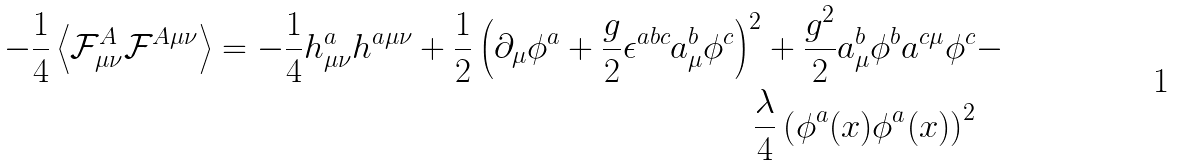Convert formula to latex. <formula><loc_0><loc_0><loc_500><loc_500>- \frac { 1 } { 4 } \left \langle \mathcal { F } ^ { A } _ { \mu \nu } \mathcal { F } ^ { A \mu \nu } \right \rangle = - \frac { 1 } { 4 } h ^ { a } _ { \mu \nu } h ^ { a \mu \nu } + \frac { 1 } { 2 } \left ( \partial _ { \mu } \phi ^ { a } + \frac { g } { 2 } \epsilon ^ { a b c } a ^ { b } _ { \mu } \phi ^ { c } \right ) ^ { 2 } + \frac { g ^ { 2 } } { 2 } a _ { \mu } ^ { b } \phi ^ { b } a ^ { c \mu } \phi ^ { c } & - \\ \frac { \lambda } { 4 } \left ( \phi ^ { a } ( x ) \phi ^ { a } ( x ) \right ) ^ { 2 } &</formula> 